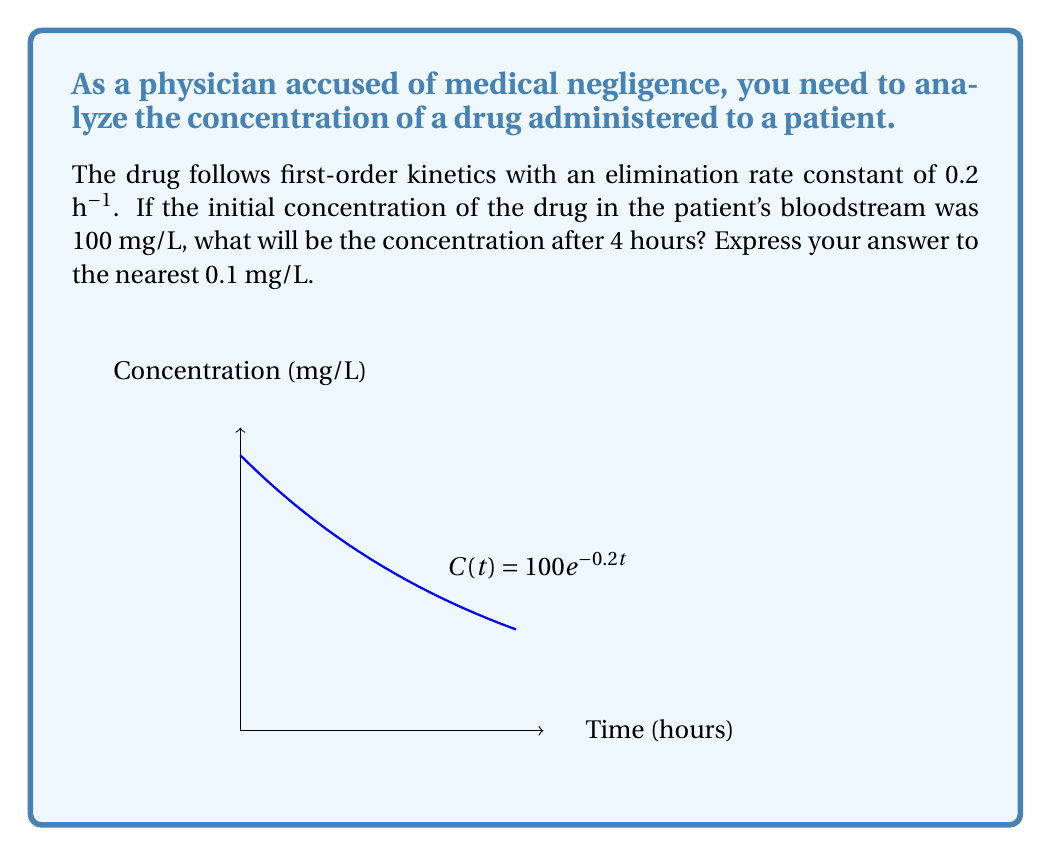Could you help me with this problem? To solve this problem, we'll use the first-order kinetics equation:

$$C(t) = C_0 e^{-kt}$$

Where:
$C(t)$ is the concentration at time $t$
$C_0$ is the initial concentration
$k$ is the elimination rate constant
$t$ is the time

Given:
$C_0 = 100$ mg/L
$k = 0.2$ h⁻¹
$t = 4$ hours

Step 1: Substitute the values into the equation:
$$C(4) = 100 e^{-0.2 \cdot 4}$$

Step 2: Simplify the exponent:
$$C(4) = 100 e^{-0.8}$$

Step 3: Calculate the exponential term:
$$e^{-0.8} \approx 0.4493$$

Step 4: Multiply:
$$C(4) = 100 \cdot 0.4493 \approx 44.93 \text{ mg/L}$$

Step 5: Round to the nearest 0.1 mg/L:
$$C(4) \approx 44.9 \text{ mg/L}$$
Answer: 44.9 mg/L 